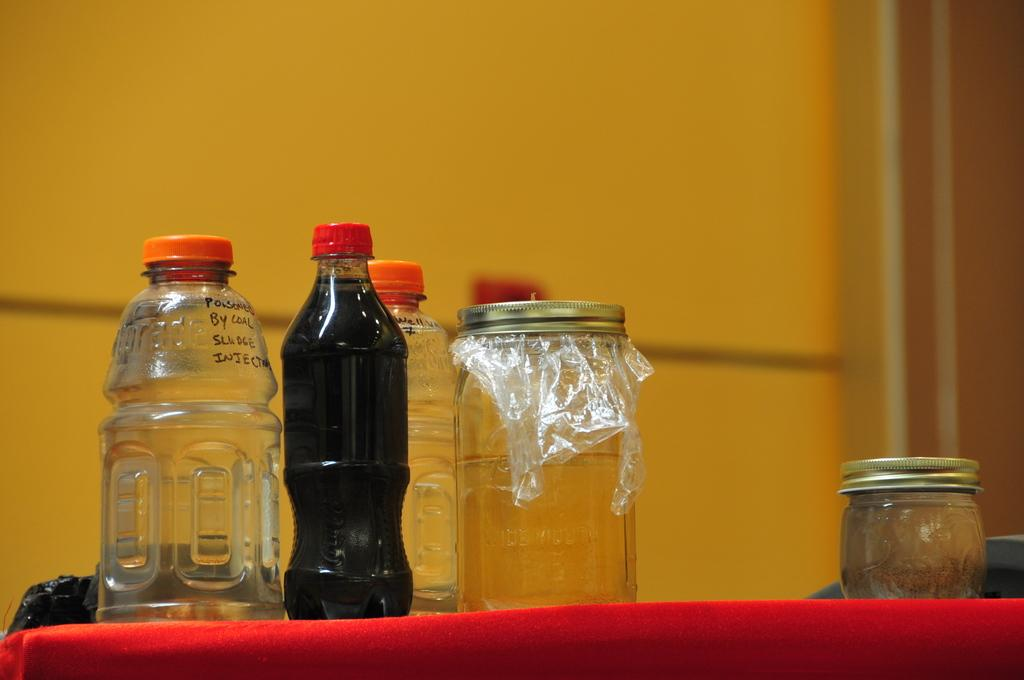<image>
Create a compact narrative representing the image presented. Some jars and bottles, one of which says "poisoned by coal sludge injection". 